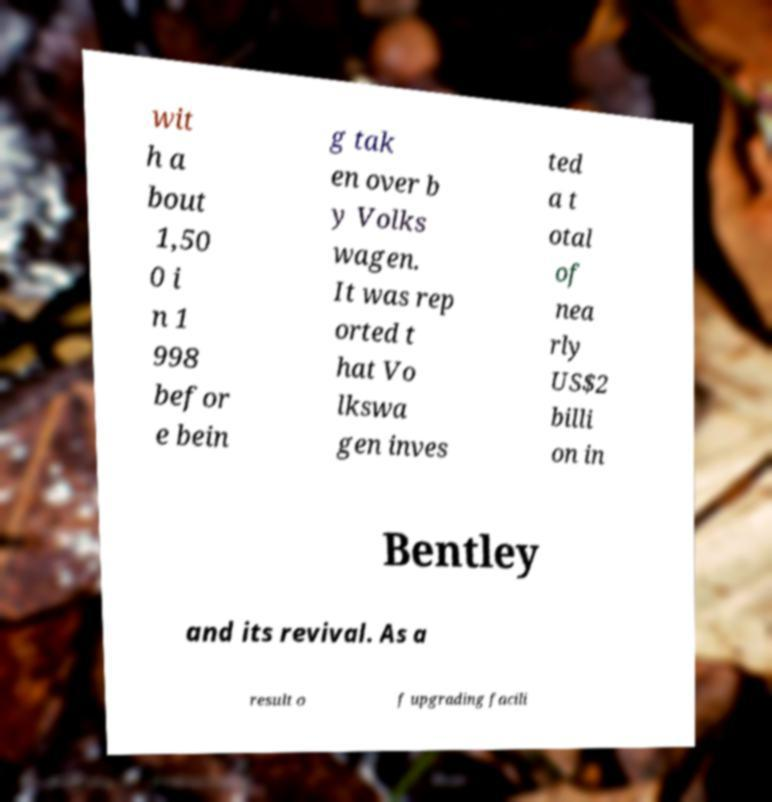I need the written content from this picture converted into text. Can you do that? wit h a bout 1,50 0 i n 1 998 befor e bein g tak en over b y Volks wagen. It was rep orted t hat Vo lkswa gen inves ted a t otal of nea rly US$2 billi on in Bentley and its revival. As a result o f upgrading facili 